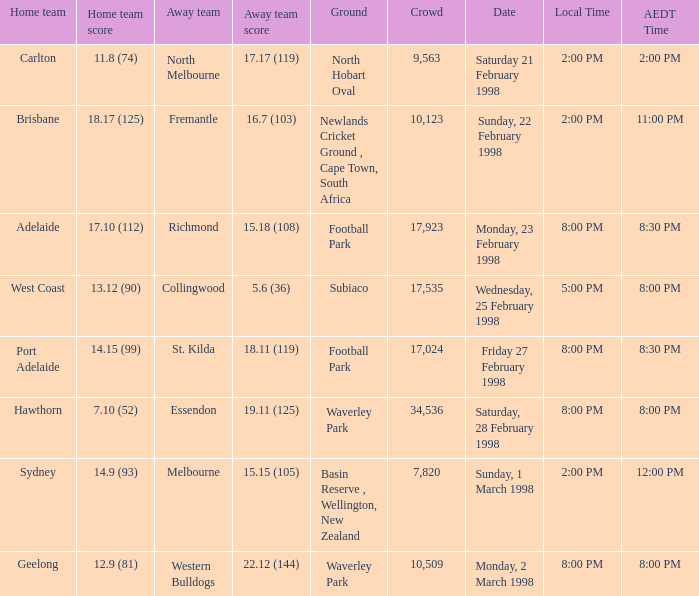Which home team's tally has an aedt time of 11:00 pm? 18.17 (125). 